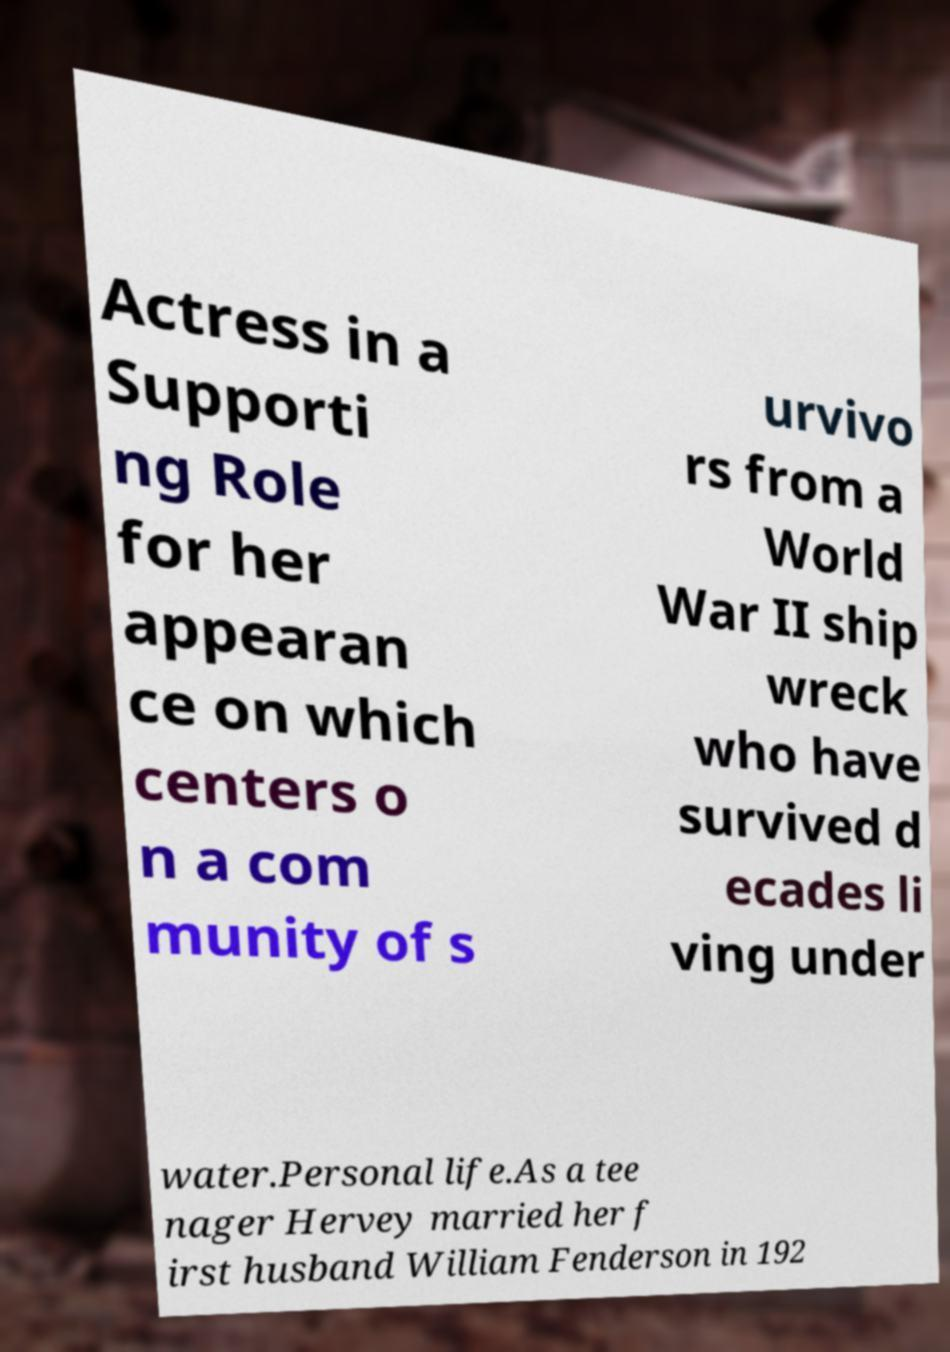There's text embedded in this image that I need extracted. Can you transcribe it verbatim? Actress in a Supporti ng Role for her appearan ce on which centers o n a com munity of s urvivo rs from a World War II ship wreck who have survived d ecades li ving under water.Personal life.As a tee nager Hervey married her f irst husband William Fenderson in 192 